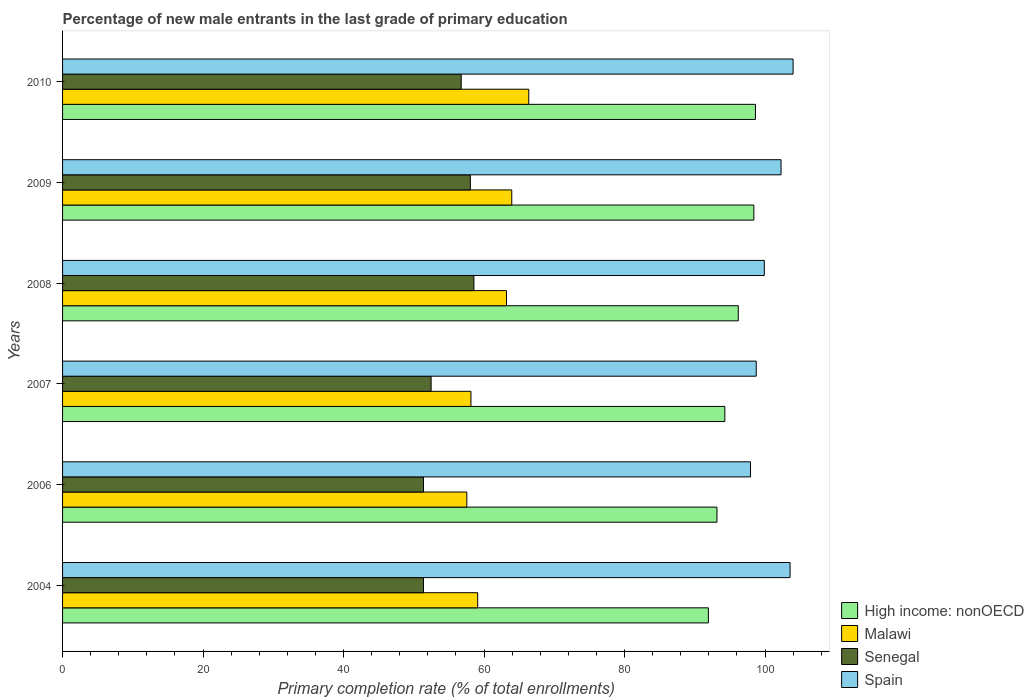How many groups of bars are there?
Provide a short and direct response. 6. Are the number of bars per tick equal to the number of legend labels?
Your answer should be very brief. Yes. How many bars are there on the 2nd tick from the top?
Provide a short and direct response. 4. How many bars are there on the 2nd tick from the bottom?
Your answer should be compact. 4. What is the percentage of new male entrants in High income: nonOECD in 2004?
Offer a terse response. 91.94. Across all years, what is the maximum percentage of new male entrants in Malawi?
Make the answer very short. 66.37. Across all years, what is the minimum percentage of new male entrants in Malawi?
Provide a succinct answer. 57.55. What is the total percentage of new male entrants in Malawi in the graph?
Provide a short and direct response. 368.3. What is the difference between the percentage of new male entrants in Senegal in 2004 and that in 2007?
Give a very brief answer. -1.09. What is the difference between the percentage of new male entrants in High income: nonOECD in 2004 and the percentage of new male entrants in Spain in 2007?
Your answer should be compact. -6.81. What is the average percentage of new male entrants in Spain per year?
Your response must be concise. 101.07. In the year 2006, what is the difference between the percentage of new male entrants in Spain and percentage of new male entrants in High income: nonOECD?
Offer a very short reply. 4.78. In how many years, is the percentage of new male entrants in Senegal greater than 92 %?
Your response must be concise. 0. What is the ratio of the percentage of new male entrants in Malawi in 2007 to that in 2009?
Give a very brief answer. 0.91. Is the difference between the percentage of new male entrants in Spain in 2006 and 2009 greater than the difference between the percentage of new male entrants in High income: nonOECD in 2006 and 2009?
Provide a succinct answer. Yes. What is the difference between the highest and the second highest percentage of new male entrants in Senegal?
Make the answer very short. 0.51. What is the difference between the highest and the lowest percentage of new male entrants in High income: nonOECD?
Your answer should be very brief. 6.7. In how many years, is the percentage of new male entrants in Spain greater than the average percentage of new male entrants in Spain taken over all years?
Offer a terse response. 3. What does the 2nd bar from the top in 2009 represents?
Give a very brief answer. Senegal. What does the 1st bar from the bottom in 2006 represents?
Offer a terse response. High income: nonOECD. How many bars are there?
Offer a very short reply. 24. How many years are there in the graph?
Your response must be concise. 6. What is the difference between two consecutive major ticks on the X-axis?
Ensure brevity in your answer.  20. Does the graph contain grids?
Ensure brevity in your answer.  No. Where does the legend appear in the graph?
Provide a short and direct response. Bottom right. What is the title of the graph?
Ensure brevity in your answer.  Percentage of new male entrants in the last grade of primary education. What is the label or title of the X-axis?
Keep it short and to the point. Primary completion rate (% of total enrollments). What is the Primary completion rate (% of total enrollments) of High income: nonOECD in 2004?
Keep it short and to the point. 91.94. What is the Primary completion rate (% of total enrollments) of Malawi in 2004?
Offer a very short reply. 59.1. What is the Primary completion rate (% of total enrollments) of Senegal in 2004?
Offer a terse response. 51.38. What is the Primary completion rate (% of total enrollments) in Spain in 2004?
Offer a very short reply. 103.57. What is the Primary completion rate (% of total enrollments) in High income: nonOECD in 2006?
Offer a terse response. 93.16. What is the Primary completion rate (% of total enrollments) of Malawi in 2006?
Your answer should be very brief. 57.55. What is the Primary completion rate (% of total enrollments) in Senegal in 2006?
Provide a short and direct response. 51.38. What is the Primary completion rate (% of total enrollments) in Spain in 2006?
Your answer should be compact. 97.93. What is the Primary completion rate (% of total enrollments) in High income: nonOECD in 2007?
Your response must be concise. 94.28. What is the Primary completion rate (% of total enrollments) of Malawi in 2007?
Give a very brief answer. 58.14. What is the Primary completion rate (% of total enrollments) of Senegal in 2007?
Your answer should be compact. 52.47. What is the Primary completion rate (% of total enrollments) of Spain in 2007?
Ensure brevity in your answer.  98.75. What is the Primary completion rate (% of total enrollments) in High income: nonOECD in 2008?
Offer a very short reply. 96.19. What is the Primary completion rate (% of total enrollments) in Malawi in 2008?
Your answer should be compact. 63.2. What is the Primary completion rate (% of total enrollments) in Senegal in 2008?
Provide a succinct answer. 58.56. What is the Primary completion rate (% of total enrollments) of Spain in 2008?
Your answer should be very brief. 99.9. What is the Primary completion rate (% of total enrollments) of High income: nonOECD in 2009?
Your answer should be very brief. 98.41. What is the Primary completion rate (% of total enrollments) of Malawi in 2009?
Your answer should be compact. 63.95. What is the Primary completion rate (% of total enrollments) of Senegal in 2009?
Give a very brief answer. 58.05. What is the Primary completion rate (% of total enrollments) of Spain in 2009?
Offer a very short reply. 102.28. What is the Primary completion rate (% of total enrollments) in High income: nonOECD in 2010?
Ensure brevity in your answer.  98.64. What is the Primary completion rate (% of total enrollments) in Malawi in 2010?
Your response must be concise. 66.37. What is the Primary completion rate (% of total enrollments) of Senegal in 2010?
Give a very brief answer. 56.75. What is the Primary completion rate (% of total enrollments) in Spain in 2010?
Your answer should be compact. 104. Across all years, what is the maximum Primary completion rate (% of total enrollments) in High income: nonOECD?
Offer a terse response. 98.64. Across all years, what is the maximum Primary completion rate (% of total enrollments) in Malawi?
Make the answer very short. 66.37. Across all years, what is the maximum Primary completion rate (% of total enrollments) in Senegal?
Keep it short and to the point. 58.56. Across all years, what is the maximum Primary completion rate (% of total enrollments) in Spain?
Keep it short and to the point. 104. Across all years, what is the minimum Primary completion rate (% of total enrollments) in High income: nonOECD?
Your response must be concise. 91.94. Across all years, what is the minimum Primary completion rate (% of total enrollments) of Malawi?
Provide a succinct answer. 57.55. Across all years, what is the minimum Primary completion rate (% of total enrollments) in Senegal?
Provide a succinct answer. 51.38. Across all years, what is the minimum Primary completion rate (% of total enrollments) in Spain?
Your response must be concise. 97.93. What is the total Primary completion rate (% of total enrollments) of High income: nonOECD in the graph?
Provide a short and direct response. 572.62. What is the total Primary completion rate (% of total enrollments) of Malawi in the graph?
Your answer should be compact. 368.3. What is the total Primary completion rate (% of total enrollments) of Senegal in the graph?
Your response must be concise. 328.59. What is the total Primary completion rate (% of total enrollments) of Spain in the graph?
Make the answer very short. 606.43. What is the difference between the Primary completion rate (% of total enrollments) in High income: nonOECD in 2004 and that in 2006?
Keep it short and to the point. -1.22. What is the difference between the Primary completion rate (% of total enrollments) of Malawi in 2004 and that in 2006?
Your answer should be very brief. 1.55. What is the difference between the Primary completion rate (% of total enrollments) of Senegal in 2004 and that in 2006?
Make the answer very short. -0. What is the difference between the Primary completion rate (% of total enrollments) in Spain in 2004 and that in 2006?
Your answer should be very brief. 5.63. What is the difference between the Primary completion rate (% of total enrollments) in High income: nonOECD in 2004 and that in 2007?
Your response must be concise. -2.35. What is the difference between the Primary completion rate (% of total enrollments) in Malawi in 2004 and that in 2007?
Make the answer very short. 0.96. What is the difference between the Primary completion rate (% of total enrollments) in Senegal in 2004 and that in 2007?
Keep it short and to the point. -1.09. What is the difference between the Primary completion rate (% of total enrollments) of Spain in 2004 and that in 2007?
Offer a very short reply. 4.82. What is the difference between the Primary completion rate (% of total enrollments) of High income: nonOECD in 2004 and that in 2008?
Give a very brief answer. -4.26. What is the difference between the Primary completion rate (% of total enrollments) of Malawi in 2004 and that in 2008?
Offer a very short reply. -4.1. What is the difference between the Primary completion rate (% of total enrollments) in Senegal in 2004 and that in 2008?
Offer a very short reply. -7.18. What is the difference between the Primary completion rate (% of total enrollments) in Spain in 2004 and that in 2008?
Ensure brevity in your answer.  3.67. What is the difference between the Primary completion rate (% of total enrollments) of High income: nonOECD in 2004 and that in 2009?
Make the answer very short. -6.47. What is the difference between the Primary completion rate (% of total enrollments) of Malawi in 2004 and that in 2009?
Your answer should be very brief. -4.85. What is the difference between the Primary completion rate (% of total enrollments) in Senegal in 2004 and that in 2009?
Provide a short and direct response. -6.67. What is the difference between the Primary completion rate (% of total enrollments) of Spain in 2004 and that in 2009?
Your answer should be very brief. 1.28. What is the difference between the Primary completion rate (% of total enrollments) of High income: nonOECD in 2004 and that in 2010?
Your answer should be compact. -6.7. What is the difference between the Primary completion rate (% of total enrollments) in Malawi in 2004 and that in 2010?
Give a very brief answer. -7.27. What is the difference between the Primary completion rate (% of total enrollments) in Senegal in 2004 and that in 2010?
Your answer should be very brief. -5.37. What is the difference between the Primary completion rate (% of total enrollments) of Spain in 2004 and that in 2010?
Ensure brevity in your answer.  -0.43. What is the difference between the Primary completion rate (% of total enrollments) in High income: nonOECD in 2006 and that in 2007?
Offer a very short reply. -1.12. What is the difference between the Primary completion rate (% of total enrollments) of Malawi in 2006 and that in 2007?
Your answer should be very brief. -0.59. What is the difference between the Primary completion rate (% of total enrollments) of Senegal in 2006 and that in 2007?
Provide a succinct answer. -1.09. What is the difference between the Primary completion rate (% of total enrollments) in Spain in 2006 and that in 2007?
Offer a terse response. -0.82. What is the difference between the Primary completion rate (% of total enrollments) of High income: nonOECD in 2006 and that in 2008?
Provide a short and direct response. -3.04. What is the difference between the Primary completion rate (% of total enrollments) in Malawi in 2006 and that in 2008?
Offer a terse response. -5.65. What is the difference between the Primary completion rate (% of total enrollments) of Senegal in 2006 and that in 2008?
Ensure brevity in your answer.  -7.18. What is the difference between the Primary completion rate (% of total enrollments) in Spain in 2006 and that in 2008?
Ensure brevity in your answer.  -1.97. What is the difference between the Primary completion rate (% of total enrollments) in High income: nonOECD in 2006 and that in 2009?
Offer a very short reply. -5.25. What is the difference between the Primary completion rate (% of total enrollments) of Malawi in 2006 and that in 2009?
Offer a very short reply. -6.4. What is the difference between the Primary completion rate (% of total enrollments) of Senegal in 2006 and that in 2009?
Keep it short and to the point. -6.67. What is the difference between the Primary completion rate (% of total enrollments) in Spain in 2006 and that in 2009?
Your response must be concise. -4.35. What is the difference between the Primary completion rate (% of total enrollments) in High income: nonOECD in 2006 and that in 2010?
Provide a short and direct response. -5.48. What is the difference between the Primary completion rate (% of total enrollments) in Malawi in 2006 and that in 2010?
Make the answer very short. -8.82. What is the difference between the Primary completion rate (% of total enrollments) of Senegal in 2006 and that in 2010?
Your answer should be very brief. -5.37. What is the difference between the Primary completion rate (% of total enrollments) in Spain in 2006 and that in 2010?
Make the answer very short. -6.06. What is the difference between the Primary completion rate (% of total enrollments) of High income: nonOECD in 2007 and that in 2008?
Your answer should be very brief. -1.91. What is the difference between the Primary completion rate (% of total enrollments) in Malawi in 2007 and that in 2008?
Make the answer very short. -5.06. What is the difference between the Primary completion rate (% of total enrollments) in Senegal in 2007 and that in 2008?
Your response must be concise. -6.09. What is the difference between the Primary completion rate (% of total enrollments) in Spain in 2007 and that in 2008?
Make the answer very short. -1.15. What is the difference between the Primary completion rate (% of total enrollments) in High income: nonOECD in 2007 and that in 2009?
Offer a terse response. -4.13. What is the difference between the Primary completion rate (% of total enrollments) of Malawi in 2007 and that in 2009?
Provide a succinct answer. -5.81. What is the difference between the Primary completion rate (% of total enrollments) of Senegal in 2007 and that in 2009?
Keep it short and to the point. -5.59. What is the difference between the Primary completion rate (% of total enrollments) in Spain in 2007 and that in 2009?
Make the answer very short. -3.53. What is the difference between the Primary completion rate (% of total enrollments) in High income: nonOECD in 2007 and that in 2010?
Ensure brevity in your answer.  -4.35. What is the difference between the Primary completion rate (% of total enrollments) in Malawi in 2007 and that in 2010?
Give a very brief answer. -8.23. What is the difference between the Primary completion rate (% of total enrollments) in Senegal in 2007 and that in 2010?
Your answer should be very brief. -4.28. What is the difference between the Primary completion rate (% of total enrollments) in Spain in 2007 and that in 2010?
Offer a terse response. -5.25. What is the difference between the Primary completion rate (% of total enrollments) in High income: nonOECD in 2008 and that in 2009?
Keep it short and to the point. -2.22. What is the difference between the Primary completion rate (% of total enrollments) of Malawi in 2008 and that in 2009?
Ensure brevity in your answer.  -0.75. What is the difference between the Primary completion rate (% of total enrollments) of Senegal in 2008 and that in 2009?
Give a very brief answer. 0.51. What is the difference between the Primary completion rate (% of total enrollments) of Spain in 2008 and that in 2009?
Ensure brevity in your answer.  -2.38. What is the difference between the Primary completion rate (% of total enrollments) of High income: nonOECD in 2008 and that in 2010?
Offer a terse response. -2.44. What is the difference between the Primary completion rate (% of total enrollments) of Malawi in 2008 and that in 2010?
Your answer should be compact. -3.17. What is the difference between the Primary completion rate (% of total enrollments) of Senegal in 2008 and that in 2010?
Your answer should be compact. 1.81. What is the difference between the Primary completion rate (% of total enrollments) of Spain in 2008 and that in 2010?
Provide a short and direct response. -4.1. What is the difference between the Primary completion rate (% of total enrollments) in High income: nonOECD in 2009 and that in 2010?
Make the answer very short. -0.22. What is the difference between the Primary completion rate (% of total enrollments) in Malawi in 2009 and that in 2010?
Offer a very short reply. -2.42. What is the difference between the Primary completion rate (% of total enrollments) of Senegal in 2009 and that in 2010?
Your response must be concise. 1.3. What is the difference between the Primary completion rate (% of total enrollments) of Spain in 2009 and that in 2010?
Provide a succinct answer. -1.71. What is the difference between the Primary completion rate (% of total enrollments) in High income: nonOECD in 2004 and the Primary completion rate (% of total enrollments) in Malawi in 2006?
Your answer should be compact. 34.39. What is the difference between the Primary completion rate (% of total enrollments) of High income: nonOECD in 2004 and the Primary completion rate (% of total enrollments) of Senegal in 2006?
Give a very brief answer. 40.56. What is the difference between the Primary completion rate (% of total enrollments) of High income: nonOECD in 2004 and the Primary completion rate (% of total enrollments) of Spain in 2006?
Your response must be concise. -6. What is the difference between the Primary completion rate (% of total enrollments) in Malawi in 2004 and the Primary completion rate (% of total enrollments) in Senegal in 2006?
Ensure brevity in your answer.  7.72. What is the difference between the Primary completion rate (% of total enrollments) in Malawi in 2004 and the Primary completion rate (% of total enrollments) in Spain in 2006?
Your response must be concise. -38.84. What is the difference between the Primary completion rate (% of total enrollments) of Senegal in 2004 and the Primary completion rate (% of total enrollments) of Spain in 2006?
Your response must be concise. -46.55. What is the difference between the Primary completion rate (% of total enrollments) of High income: nonOECD in 2004 and the Primary completion rate (% of total enrollments) of Malawi in 2007?
Keep it short and to the point. 33.8. What is the difference between the Primary completion rate (% of total enrollments) of High income: nonOECD in 2004 and the Primary completion rate (% of total enrollments) of Senegal in 2007?
Ensure brevity in your answer.  39.47. What is the difference between the Primary completion rate (% of total enrollments) of High income: nonOECD in 2004 and the Primary completion rate (% of total enrollments) of Spain in 2007?
Provide a succinct answer. -6.81. What is the difference between the Primary completion rate (% of total enrollments) in Malawi in 2004 and the Primary completion rate (% of total enrollments) in Senegal in 2007?
Offer a very short reply. 6.63. What is the difference between the Primary completion rate (% of total enrollments) of Malawi in 2004 and the Primary completion rate (% of total enrollments) of Spain in 2007?
Ensure brevity in your answer.  -39.65. What is the difference between the Primary completion rate (% of total enrollments) in Senegal in 2004 and the Primary completion rate (% of total enrollments) in Spain in 2007?
Offer a very short reply. -47.37. What is the difference between the Primary completion rate (% of total enrollments) in High income: nonOECD in 2004 and the Primary completion rate (% of total enrollments) in Malawi in 2008?
Offer a terse response. 28.74. What is the difference between the Primary completion rate (% of total enrollments) in High income: nonOECD in 2004 and the Primary completion rate (% of total enrollments) in Senegal in 2008?
Make the answer very short. 33.38. What is the difference between the Primary completion rate (% of total enrollments) in High income: nonOECD in 2004 and the Primary completion rate (% of total enrollments) in Spain in 2008?
Your answer should be compact. -7.96. What is the difference between the Primary completion rate (% of total enrollments) in Malawi in 2004 and the Primary completion rate (% of total enrollments) in Senegal in 2008?
Keep it short and to the point. 0.54. What is the difference between the Primary completion rate (% of total enrollments) of Malawi in 2004 and the Primary completion rate (% of total enrollments) of Spain in 2008?
Give a very brief answer. -40.8. What is the difference between the Primary completion rate (% of total enrollments) of Senegal in 2004 and the Primary completion rate (% of total enrollments) of Spain in 2008?
Make the answer very short. -48.52. What is the difference between the Primary completion rate (% of total enrollments) in High income: nonOECD in 2004 and the Primary completion rate (% of total enrollments) in Malawi in 2009?
Provide a short and direct response. 27.99. What is the difference between the Primary completion rate (% of total enrollments) of High income: nonOECD in 2004 and the Primary completion rate (% of total enrollments) of Senegal in 2009?
Your response must be concise. 33.88. What is the difference between the Primary completion rate (% of total enrollments) in High income: nonOECD in 2004 and the Primary completion rate (% of total enrollments) in Spain in 2009?
Offer a terse response. -10.35. What is the difference between the Primary completion rate (% of total enrollments) of Malawi in 2004 and the Primary completion rate (% of total enrollments) of Senegal in 2009?
Keep it short and to the point. 1.04. What is the difference between the Primary completion rate (% of total enrollments) in Malawi in 2004 and the Primary completion rate (% of total enrollments) in Spain in 2009?
Make the answer very short. -43.19. What is the difference between the Primary completion rate (% of total enrollments) in Senegal in 2004 and the Primary completion rate (% of total enrollments) in Spain in 2009?
Your answer should be compact. -50.9. What is the difference between the Primary completion rate (% of total enrollments) in High income: nonOECD in 2004 and the Primary completion rate (% of total enrollments) in Malawi in 2010?
Make the answer very short. 25.57. What is the difference between the Primary completion rate (% of total enrollments) in High income: nonOECD in 2004 and the Primary completion rate (% of total enrollments) in Senegal in 2010?
Keep it short and to the point. 35.19. What is the difference between the Primary completion rate (% of total enrollments) in High income: nonOECD in 2004 and the Primary completion rate (% of total enrollments) in Spain in 2010?
Ensure brevity in your answer.  -12.06. What is the difference between the Primary completion rate (% of total enrollments) of Malawi in 2004 and the Primary completion rate (% of total enrollments) of Senegal in 2010?
Provide a succinct answer. 2.35. What is the difference between the Primary completion rate (% of total enrollments) of Malawi in 2004 and the Primary completion rate (% of total enrollments) of Spain in 2010?
Give a very brief answer. -44.9. What is the difference between the Primary completion rate (% of total enrollments) in Senegal in 2004 and the Primary completion rate (% of total enrollments) in Spain in 2010?
Offer a terse response. -52.62. What is the difference between the Primary completion rate (% of total enrollments) of High income: nonOECD in 2006 and the Primary completion rate (% of total enrollments) of Malawi in 2007?
Keep it short and to the point. 35.02. What is the difference between the Primary completion rate (% of total enrollments) in High income: nonOECD in 2006 and the Primary completion rate (% of total enrollments) in Senegal in 2007?
Provide a short and direct response. 40.69. What is the difference between the Primary completion rate (% of total enrollments) in High income: nonOECD in 2006 and the Primary completion rate (% of total enrollments) in Spain in 2007?
Provide a short and direct response. -5.59. What is the difference between the Primary completion rate (% of total enrollments) of Malawi in 2006 and the Primary completion rate (% of total enrollments) of Senegal in 2007?
Provide a succinct answer. 5.08. What is the difference between the Primary completion rate (% of total enrollments) in Malawi in 2006 and the Primary completion rate (% of total enrollments) in Spain in 2007?
Offer a terse response. -41.2. What is the difference between the Primary completion rate (% of total enrollments) of Senegal in 2006 and the Primary completion rate (% of total enrollments) of Spain in 2007?
Provide a short and direct response. -47.37. What is the difference between the Primary completion rate (% of total enrollments) in High income: nonOECD in 2006 and the Primary completion rate (% of total enrollments) in Malawi in 2008?
Make the answer very short. 29.96. What is the difference between the Primary completion rate (% of total enrollments) in High income: nonOECD in 2006 and the Primary completion rate (% of total enrollments) in Senegal in 2008?
Offer a terse response. 34.6. What is the difference between the Primary completion rate (% of total enrollments) in High income: nonOECD in 2006 and the Primary completion rate (% of total enrollments) in Spain in 2008?
Offer a very short reply. -6.74. What is the difference between the Primary completion rate (% of total enrollments) in Malawi in 2006 and the Primary completion rate (% of total enrollments) in Senegal in 2008?
Your answer should be compact. -1.01. What is the difference between the Primary completion rate (% of total enrollments) in Malawi in 2006 and the Primary completion rate (% of total enrollments) in Spain in 2008?
Offer a terse response. -42.35. What is the difference between the Primary completion rate (% of total enrollments) in Senegal in 2006 and the Primary completion rate (% of total enrollments) in Spain in 2008?
Keep it short and to the point. -48.52. What is the difference between the Primary completion rate (% of total enrollments) of High income: nonOECD in 2006 and the Primary completion rate (% of total enrollments) of Malawi in 2009?
Make the answer very short. 29.21. What is the difference between the Primary completion rate (% of total enrollments) of High income: nonOECD in 2006 and the Primary completion rate (% of total enrollments) of Senegal in 2009?
Give a very brief answer. 35.11. What is the difference between the Primary completion rate (% of total enrollments) of High income: nonOECD in 2006 and the Primary completion rate (% of total enrollments) of Spain in 2009?
Your answer should be very brief. -9.12. What is the difference between the Primary completion rate (% of total enrollments) of Malawi in 2006 and the Primary completion rate (% of total enrollments) of Senegal in 2009?
Offer a terse response. -0.5. What is the difference between the Primary completion rate (% of total enrollments) of Malawi in 2006 and the Primary completion rate (% of total enrollments) of Spain in 2009?
Your response must be concise. -44.73. What is the difference between the Primary completion rate (% of total enrollments) of Senegal in 2006 and the Primary completion rate (% of total enrollments) of Spain in 2009?
Ensure brevity in your answer.  -50.9. What is the difference between the Primary completion rate (% of total enrollments) of High income: nonOECD in 2006 and the Primary completion rate (% of total enrollments) of Malawi in 2010?
Provide a short and direct response. 26.79. What is the difference between the Primary completion rate (% of total enrollments) of High income: nonOECD in 2006 and the Primary completion rate (% of total enrollments) of Senegal in 2010?
Your response must be concise. 36.41. What is the difference between the Primary completion rate (% of total enrollments) in High income: nonOECD in 2006 and the Primary completion rate (% of total enrollments) in Spain in 2010?
Your answer should be very brief. -10.84. What is the difference between the Primary completion rate (% of total enrollments) in Malawi in 2006 and the Primary completion rate (% of total enrollments) in Senegal in 2010?
Keep it short and to the point. 0.8. What is the difference between the Primary completion rate (% of total enrollments) in Malawi in 2006 and the Primary completion rate (% of total enrollments) in Spain in 2010?
Offer a very short reply. -46.45. What is the difference between the Primary completion rate (% of total enrollments) of Senegal in 2006 and the Primary completion rate (% of total enrollments) of Spain in 2010?
Your answer should be very brief. -52.62. What is the difference between the Primary completion rate (% of total enrollments) in High income: nonOECD in 2007 and the Primary completion rate (% of total enrollments) in Malawi in 2008?
Your answer should be very brief. 31.09. What is the difference between the Primary completion rate (% of total enrollments) of High income: nonOECD in 2007 and the Primary completion rate (% of total enrollments) of Senegal in 2008?
Give a very brief answer. 35.72. What is the difference between the Primary completion rate (% of total enrollments) of High income: nonOECD in 2007 and the Primary completion rate (% of total enrollments) of Spain in 2008?
Provide a succinct answer. -5.62. What is the difference between the Primary completion rate (% of total enrollments) in Malawi in 2007 and the Primary completion rate (% of total enrollments) in Senegal in 2008?
Offer a very short reply. -0.42. What is the difference between the Primary completion rate (% of total enrollments) of Malawi in 2007 and the Primary completion rate (% of total enrollments) of Spain in 2008?
Your answer should be very brief. -41.76. What is the difference between the Primary completion rate (% of total enrollments) in Senegal in 2007 and the Primary completion rate (% of total enrollments) in Spain in 2008?
Your answer should be very brief. -47.43. What is the difference between the Primary completion rate (% of total enrollments) of High income: nonOECD in 2007 and the Primary completion rate (% of total enrollments) of Malawi in 2009?
Make the answer very short. 30.33. What is the difference between the Primary completion rate (% of total enrollments) in High income: nonOECD in 2007 and the Primary completion rate (% of total enrollments) in Senegal in 2009?
Offer a very short reply. 36.23. What is the difference between the Primary completion rate (% of total enrollments) in High income: nonOECD in 2007 and the Primary completion rate (% of total enrollments) in Spain in 2009?
Provide a short and direct response. -8. What is the difference between the Primary completion rate (% of total enrollments) in Malawi in 2007 and the Primary completion rate (% of total enrollments) in Senegal in 2009?
Your answer should be very brief. 0.08. What is the difference between the Primary completion rate (% of total enrollments) in Malawi in 2007 and the Primary completion rate (% of total enrollments) in Spain in 2009?
Give a very brief answer. -44.15. What is the difference between the Primary completion rate (% of total enrollments) of Senegal in 2007 and the Primary completion rate (% of total enrollments) of Spain in 2009?
Ensure brevity in your answer.  -49.82. What is the difference between the Primary completion rate (% of total enrollments) in High income: nonOECD in 2007 and the Primary completion rate (% of total enrollments) in Malawi in 2010?
Offer a very short reply. 27.91. What is the difference between the Primary completion rate (% of total enrollments) in High income: nonOECD in 2007 and the Primary completion rate (% of total enrollments) in Senegal in 2010?
Your answer should be very brief. 37.53. What is the difference between the Primary completion rate (% of total enrollments) of High income: nonOECD in 2007 and the Primary completion rate (% of total enrollments) of Spain in 2010?
Offer a very short reply. -9.72. What is the difference between the Primary completion rate (% of total enrollments) of Malawi in 2007 and the Primary completion rate (% of total enrollments) of Senegal in 2010?
Your answer should be compact. 1.39. What is the difference between the Primary completion rate (% of total enrollments) in Malawi in 2007 and the Primary completion rate (% of total enrollments) in Spain in 2010?
Provide a short and direct response. -45.86. What is the difference between the Primary completion rate (% of total enrollments) of Senegal in 2007 and the Primary completion rate (% of total enrollments) of Spain in 2010?
Your response must be concise. -51.53. What is the difference between the Primary completion rate (% of total enrollments) in High income: nonOECD in 2008 and the Primary completion rate (% of total enrollments) in Malawi in 2009?
Keep it short and to the point. 32.25. What is the difference between the Primary completion rate (% of total enrollments) of High income: nonOECD in 2008 and the Primary completion rate (% of total enrollments) of Senegal in 2009?
Provide a succinct answer. 38.14. What is the difference between the Primary completion rate (% of total enrollments) in High income: nonOECD in 2008 and the Primary completion rate (% of total enrollments) in Spain in 2009?
Your answer should be compact. -6.09. What is the difference between the Primary completion rate (% of total enrollments) of Malawi in 2008 and the Primary completion rate (% of total enrollments) of Senegal in 2009?
Keep it short and to the point. 5.14. What is the difference between the Primary completion rate (% of total enrollments) in Malawi in 2008 and the Primary completion rate (% of total enrollments) in Spain in 2009?
Provide a short and direct response. -39.09. What is the difference between the Primary completion rate (% of total enrollments) in Senegal in 2008 and the Primary completion rate (% of total enrollments) in Spain in 2009?
Ensure brevity in your answer.  -43.72. What is the difference between the Primary completion rate (% of total enrollments) in High income: nonOECD in 2008 and the Primary completion rate (% of total enrollments) in Malawi in 2010?
Your response must be concise. 29.83. What is the difference between the Primary completion rate (% of total enrollments) in High income: nonOECD in 2008 and the Primary completion rate (% of total enrollments) in Senegal in 2010?
Your answer should be very brief. 39.45. What is the difference between the Primary completion rate (% of total enrollments) in High income: nonOECD in 2008 and the Primary completion rate (% of total enrollments) in Spain in 2010?
Give a very brief answer. -7.8. What is the difference between the Primary completion rate (% of total enrollments) of Malawi in 2008 and the Primary completion rate (% of total enrollments) of Senegal in 2010?
Your answer should be very brief. 6.45. What is the difference between the Primary completion rate (% of total enrollments) in Malawi in 2008 and the Primary completion rate (% of total enrollments) in Spain in 2010?
Give a very brief answer. -40.8. What is the difference between the Primary completion rate (% of total enrollments) of Senegal in 2008 and the Primary completion rate (% of total enrollments) of Spain in 2010?
Your answer should be compact. -45.44. What is the difference between the Primary completion rate (% of total enrollments) of High income: nonOECD in 2009 and the Primary completion rate (% of total enrollments) of Malawi in 2010?
Ensure brevity in your answer.  32.04. What is the difference between the Primary completion rate (% of total enrollments) in High income: nonOECD in 2009 and the Primary completion rate (% of total enrollments) in Senegal in 2010?
Provide a short and direct response. 41.66. What is the difference between the Primary completion rate (% of total enrollments) in High income: nonOECD in 2009 and the Primary completion rate (% of total enrollments) in Spain in 2010?
Offer a very short reply. -5.59. What is the difference between the Primary completion rate (% of total enrollments) in Malawi in 2009 and the Primary completion rate (% of total enrollments) in Senegal in 2010?
Provide a succinct answer. 7.2. What is the difference between the Primary completion rate (% of total enrollments) in Malawi in 2009 and the Primary completion rate (% of total enrollments) in Spain in 2010?
Ensure brevity in your answer.  -40.05. What is the difference between the Primary completion rate (% of total enrollments) of Senegal in 2009 and the Primary completion rate (% of total enrollments) of Spain in 2010?
Provide a succinct answer. -45.94. What is the average Primary completion rate (% of total enrollments) in High income: nonOECD per year?
Keep it short and to the point. 95.44. What is the average Primary completion rate (% of total enrollments) of Malawi per year?
Ensure brevity in your answer.  61.38. What is the average Primary completion rate (% of total enrollments) in Senegal per year?
Your answer should be very brief. 54.76. What is the average Primary completion rate (% of total enrollments) in Spain per year?
Your answer should be very brief. 101.07. In the year 2004, what is the difference between the Primary completion rate (% of total enrollments) in High income: nonOECD and Primary completion rate (% of total enrollments) in Malawi?
Your answer should be very brief. 32.84. In the year 2004, what is the difference between the Primary completion rate (% of total enrollments) in High income: nonOECD and Primary completion rate (% of total enrollments) in Senegal?
Ensure brevity in your answer.  40.56. In the year 2004, what is the difference between the Primary completion rate (% of total enrollments) of High income: nonOECD and Primary completion rate (% of total enrollments) of Spain?
Offer a very short reply. -11.63. In the year 2004, what is the difference between the Primary completion rate (% of total enrollments) of Malawi and Primary completion rate (% of total enrollments) of Senegal?
Offer a very short reply. 7.72. In the year 2004, what is the difference between the Primary completion rate (% of total enrollments) of Malawi and Primary completion rate (% of total enrollments) of Spain?
Make the answer very short. -44.47. In the year 2004, what is the difference between the Primary completion rate (% of total enrollments) in Senegal and Primary completion rate (% of total enrollments) in Spain?
Ensure brevity in your answer.  -52.19. In the year 2006, what is the difference between the Primary completion rate (% of total enrollments) in High income: nonOECD and Primary completion rate (% of total enrollments) in Malawi?
Provide a succinct answer. 35.61. In the year 2006, what is the difference between the Primary completion rate (% of total enrollments) of High income: nonOECD and Primary completion rate (% of total enrollments) of Senegal?
Your response must be concise. 41.78. In the year 2006, what is the difference between the Primary completion rate (% of total enrollments) in High income: nonOECD and Primary completion rate (% of total enrollments) in Spain?
Your answer should be very brief. -4.78. In the year 2006, what is the difference between the Primary completion rate (% of total enrollments) in Malawi and Primary completion rate (% of total enrollments) in Senegal?
Your answer should be compact. 6.17. In the year 2006, what is the difference between the Primary completion rate (% of total enrollments) in Malawi and Primary completion rate (% of total enrollments) in Spain?
Make the answer very short. -40.39. In the year 2006, what is the difference between the Primary completion rate (% of total enrollments) in Senegal and Primary completion rate (% of total enrollments) in Spain?
Provide a short and direct response. -46.55. In the year 2007, what is the difference between the Primary completion rate (% of total enrollments) in High income: nonOECD and Primary completion rate (% of total enrollments) in Malawi?
Keep it short and to the point. 36.14. In the year 2007, what is the difference between the Primary completion rate (% of total enrollments) of High income: nonOECD and Primary completion rate (% of total enrollments) of Senegal?
Your response must be concise. 41.82. In the year 2007, what is the difference between the Primary completion rate (% of total enrollments) in High income: nonOECD and Primary completion rate (% of total enrollments) in Spain?
Offer a very short reply. -4.47. In the year 2007, what is the difference between the Primary completion rate (% of total enrollments) of Malawi and Primary completion rate (% of total enrollments) of Senegal?
Offer a very short reply. 5.67. In the year 2007, what is the difference between the Primary completion rate (% of total enrollments) of Malawi and Primary completion rate (% of total enrollments) of Spain?
Your answer should be very brief. -40.61. In the year 2007, what is the difference between the Primary completion rate (% of total enrollments) of Senegal and Primary completion rate (% of total enrollments) of Spain?
Offer a terse response. -46.28. In the year 2008, what is the difference between the Primary completion rate (% of total enrollments) in High income: nonOECD and Primary completion rate (% of total enrollments) in Malawi?
Your response must be concise. 33. In the year 2008, what is the difference between the Primary completion rate (% of total enrollments) of High income: nonOECD and Primary completion rate (% of total enrollments) of Senegal?
Your answer should be compact. 37.64. In the year 2008, what is the difference between the Primary completion rate (% of total enrollments) in High income: nonOECD and Primary completion rate (% of total enrollments) in Spain?
Provide a short and direct response. -3.71. In the year 2008, what is the difference between the Primary completion rate (% of total enrollments) of Malawi and Primary completion rate (% of total enrollments) of Senegal?
Keep it short and to the point. 4.64. In the year 2008, what is the difference between the Primary completion rate (% of total enrollments) in Malawi and Primary completion rate (% of total enrollments) in Spain?
Your response must be concise. -36.7. In the year 2008, what is the difference between the Primary completion rate (% of total enrollments) of Senegal and Primary completion rate (% of total enrollments) of Spain?
Offer a very short reply. -41.34. In the year 2009, what is the difference between the Primary completion rate (% of total enrollments) of High income: nonOECD and Primary completion rate (% of total enrollments) of Malawi?
Ensure brevity in your answer.  34.46. In the year 2009, what is the difference between the Primary completion rate (% of total enrollments) of High income: nonOECD and Primary completion rate (% of total enrollments) of Senegal?
Make the answer very short. 40.36. In the year 2009, what is the difference between the Primary completion rate (% of total enrollments) of High income: nonOECD and Primary completion rate (% of total enrollments) of Spain?
Make the answer very short. -3.87. In the year 2009, what is the difference between the Primary completion rate (% of total enrollments) of Malawi and Primary completion rate (% of total enrollments) of Senegal?
Your answer should be very brief. 5.89. In the year 2009, what is the difference between the Primary completion rate (% of total enrollments) of Malawi and Primary completion rate (% of total enrollments) of Spain?
Give a very brief answer. -38.34. In the year 2009, what is the difference between the Primary completion rate (% of total enrollments) in Senegal and Primary completion rate (% of total enrollments) in Spain?
Your response must be concise. -44.23. In the year 2010, what is the difference between the Primary completion rate (% of total enrollments) of High income: nonOECD and Primary completion rate (% of total enrollments) of Malawi?
Provide a succinct answer. 32.27. In the year 2010, what is the difference between the Primary completion rate (% of total enrollments) of High income: nonOECD and Primary completion rate (% of total enrollments) of Senegal?
Make the answer very short. 41.89. In the year 2010, what is the difference between the Primary completion rate (% of total enrollments) of High income: nonOECD and Primary completion rate (% of total enrollments) of Spain?
Your answer should be very brief. -5.36. In the year 2010, what is the difference between the Primary completion rate (% of total enrollments) in Malawi and Primary completion rate (% of total enrollments) in Senegal?
Ensure brevity in your answer.  9.62. In the year 2010, what is the difference between the Primary completion rate (% of total enrollments) of Malawi and Primary completion rate (% of total enrollments) of Spain?
Offer a terse response. -37.63. In the year 2010, what is the difference between the Primary completion rate (% of total enrollments) of Senegal and Primary completion rate (% of total enrollments) of Spain?
Keep it short and to the point. -47.25. What is the ratio of the Primary completion rate (% of total enrollments) of High income: nonOECD in 2004 to that in 2006?
Ensure brevity in your answer.  0.99. What is the ratio of the Primary completion rate (% of total enrollments) of Malawi in 2004 to that in 2006?
Make the answer very short. 1.03. What is the ratio of the Primary completion rate (% of total enrollments) of Senegal in 2004 to that in 2006?
Provide a short and direct response. 1. What is the ratio of the Primary completion rate (% of total enrollments) of Spain in 2004 to that in 2006?
Provide a short and direct response. 1.06. What is the ratio of the Primary completion rate (% of total enrollments) of High income: nonOECD in 2004 to that in 2007?
Provide a short and direct response. 0.98. What is the ratio of the Primary completion rate (% of total enrollments) in Malawi in 2004 to that in 2007?
Keep it short and to the point. 1.02. What is the ratio of the Primary completion rate (% of total enrollments) in Senegal in 2004 to that in 2007?
Your response must be concise. 0.98. What is the ratio of the Primary completion rate (% of total enrollments) of Spain in 2004 to that in 2007?
Make the answer very short. 1.05. What is the ratio of the Primary completion rate (% of total enrollments) in High income: nonOECD in 2004 to that in 2008?
Your answer should be compact. 0.96. What is the ratio of the Primary completion rate (% of total enrollments) in Malawi in 2004 to that in 2008?
Provide a short and direct response. 0.94. What is the ratio of the Primary completion rate (% of total enrollments) in Senegal in 2004 to that in 2008?
Give a very brief answer. 0.88. What is the ratio of the Primary completion rate (% of total enrollments) of Spain in 2004 to that in 2008?
Provide a succinct answer. 1.04. What is the ratio of the Primary completion rate (% of total enrollments) of High income: nonOECD in 2004 to that in 2009?
Your answer should be compact. 0.93. What is the ratio of the Primary completion rate (% of total enrollments) in Malawi in 2004 to that in 2009?
Give a very brief answer. 0.92. What is the ratio of the Primary completion rate (% of total enrollments) in Senegal in 2004 to that in 2009?
Make the answer very short. 0.89. What is the ratio of the Primary completion rate (% of total enrollments) of Spain in 2004 to that in 2009?
Keep it short and to the point. 1.01. What is the ratio of the Primary completion rate (% of total enrollments) of High income: nonOECD in 2004 to that in 2010?
Ensure brevity in your answer.  0.93. What is the ratio of the Primary completion rate (% of total enrollments) of Malawi in 2004 to that in 2010?
Provide a succinct answer. 0.89. What is the ratio of the Primary completion rate (% of total enrollments) of Senegal in 2004 to that in 2010?
Keep it short and to the point. 0.91. What is the ratio of the Primary completion rate (% of total enrollments) of Spain in 2004 to that in 2010?
Give a very brief answer. 1. What is the ratio of the Primary completion rate (% of total enrollments) in High income: nonOECD in 2006 to that in 2007?
Your answer should be compact. 0.99. What is the ratio of the Primary completion rate (% of total enrollments) in Malawi in 2006 to that in 2007?
Keep it short and to the point. 0.99. What is the ratio of the Primary completion rate (% of total enrollments) in Senegal in 2006 to that in 2007?
Give a very brief answer. 0.98. What is the ratio of the Primary completion rate (% of total enrollments) in High income: nonOECD in 2006 to that in 2008?
Provide a short and direct response. 0.97. What is the ratio of the Primary completion rate (% of total enrollments) of Malawi in 2006 to that in 2008?
Offer a very short reply. 0.91. What is the ratio of the Primary completion rate (% of total enrollments) in Senegal in 2006 to that in 2008?
Ensure brevity in your answer.  0.88. What is the ratio of the Primary completion rate (% of total enrollments) in Spain in 2006 to that in 2008?
Keep it short and to the point. 0.98. What is the ratio of the Primary completion rate (% of total enrollments) in High income: nonOECD in 2006 to that in 2009?
Keep it short and to the point. 0.95. What is the ratio of the Primary completion rate (% of total enrollments) of Malawi in 2006 to that in 2009?
Provide a succinct answer. 0.9. What is the ratio of the Primary completion rate (% of total enrollments) in Senegal in 2006 to that in 2009?
Your answer should be very brief. 0.89. What is the ratio of the Primary completion rate (% of total enrollments) of Spain in 2006 to that in 2009?
Offer a terse response. 0.96. What is the ratio of the Primary completion rate (% of total enrollments) in High income: nonOECD in 2006 to that in 2010?
Keep it short and to the point. 0.94. What is the ratio of the Primary completion rate (% of total enrollments) of Malawi in 2006 to that in 2010?
Give a very brief answer. 0.87. What is the ratio of the Primary completion rate (% of total enrollments) in Senegal in 2006 to that in 2010?
Your answer should be very brief. 0.91. What is the ratio of the Primary completion rate (% of total enrollments) of Spain in 2006 to that in 2010?
Your response must be concise. 0.94. What is the ratio of the Primary completion rate (% of total enrollments) in High income: nonOECD in 2007 to that in 2008?
Offer a terse response. 0.98. What is the ratio of the Primary completion rate (% of total enrollments) in Malawi in 2007 to that in 2008?
Ensure brevity in your answer.  0.92. What is the ratio of the Primary completion rate (% of total enrollments) in Senegal in 2007 to that in 2008?
Your response must be concise. 0.9. What is the ratio of the Primary completion rate (% of total enrollments) of High income: nonOECD in 2007 to that in 2009?
Make the answer very short. 0.96. What is the ratio of the Primary completion rate (% of total enrollments) in Malawi in 2007 to that in 2009?
Your answer should be very brief. 0.91. What is the ratio of the Primary completion rate (% of total enrollments) in Senegal in 2007 to that in 2009?
Provide a short and direct response. 0.9. What is the ratio of the Primary completion rate (% of total enrollments) of Spain in 2007 to that in 2009?
Provide a short and direct response. 0.97. What is the ratio of the Primary completion rate (% of total enrollments) in High income: nonOECD in 2007 to that in 2010?
Keep it short and to the point. 0.96. What is the ratio of the Primary completion rate (% of total enrollments) in Malawi in 2007 to that in 2010?
Ensure brevity in your answer.  0.88. What is the ratio of the Primary completion rate (% of total enrollments) of Senegal in 2007 to that in 2010?
Your response must be concise. 0.92. What is the ratio of the Primary completion rate (% of total enrollments) in Spain in 2007 to that in 2010?
Offer a terse response. 0.95. What is the ratio of the Primary completion rate (% of total enrollments) in High income: nonOECD in 2008 to that in 2009?
Give a very brief answer. 0.98. What is the ratio of the Primary completion rate (% of total enrollments) in Senegal in 2008 to that in 2009?
Provide a succinct answer. 1.01. What is the ratio of the Primary completion rate (% of total enrollments) of Spain in 2008 to that in 2009?
Ensure brevity in your answer.  0.98. What is the ratio of the Primary completion rate (% of total enrollments) in High income: nonOECD in 2008 to that in 2010?
Provide a succinct answer. 0.98. What is the ratio of the Primary completion rate (% of total enrollments) of Malawi in 2008 to that in 2010?
Provide a short and direct response. 0.95. What is the ratio of the Primary completion rate (% of total enrollments) in Senegal in 2008 to that in 2010?
Offer a very short reply. 1.03. What is the ratio of the Primary completion rate (% of total enrollments) of Spain in 2008 to that in 2010?
Offer a terse response. 0.96. What is the ratio of the Primary completion rate (% of total enrollments) in High income: nonOECD in 2009 to that in 2010?
Your answer should be very brief. 1. What is the ratio of the Primary completion rate (% of total enrollments) in Malawi in 2009 to that in 2010?
Provide a succinct answer. 0.96. What is the ratio of the Primary completion rate (% of total enrollments) of Senegal in 2009 to that in 2010?
Keep it short and to the point. 1.02. What is the ratio of the Primary completion rate (% of total enrollments) of Spain in 2009 to that in 2010?
Your answer should be very brief. 0.98. What is the difference between the highest and the second highest Primary completion rate (% of total enrollments) in High income: nonOECD?
Your response must be concise. 0.22. What is the difference between the highest and the second highest Primary completion rate (% of total enrollments) of Malawi?
Offer a very short reply. 2.42. What is the difference between the highest and the second highest Primary completion rate (% of total enrollments) of Senegal?
Offer a terse response. 0.51. What is the difference between the highest and the second highest Primary completion rate (% of total enrollments) of Spain?
Provide a short and direct response. 0.43. What is the difference between the highest and the lowest Primary completion rate (% of total enrollments) in High income: nonOECD?
Offer a terse response. 6.7. What is the difference between the highest and the lowest Primary completion rate (% of total enrollments) in Malawi?
Make the answer very short. 8.82. What is the difference between the highest and the lowest Primary completion rate (% of total enrollments) of Senegal?
Provide a short and direct response. 7.18. What is the difference between the highest and the lowest Primary completion rate (% of total enrollments) of Spain?
Give a very brief answer. 6.06. 